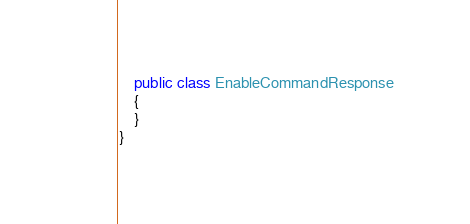<code> <loc_0><loc_0><loc_500><loc_500><_C#_>	public class EnableCommandResponse
	{
	}
}
</code> 